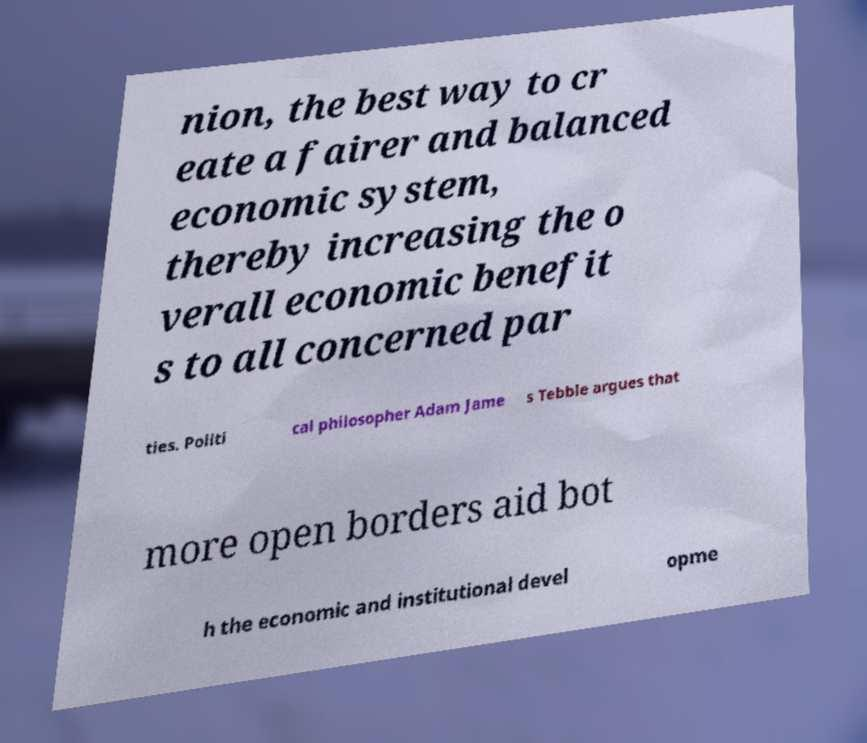I need the written content from this picture converted into text. Can you do that? nion, the best way to cr eate a fairer and balanced economic system, thereby increasing the o verall economic benefit s to all concerned par ties. Politi cal philosopher Adam Jame s Tebble argues that more open borders aid bot h the economic and institutional devel opme 